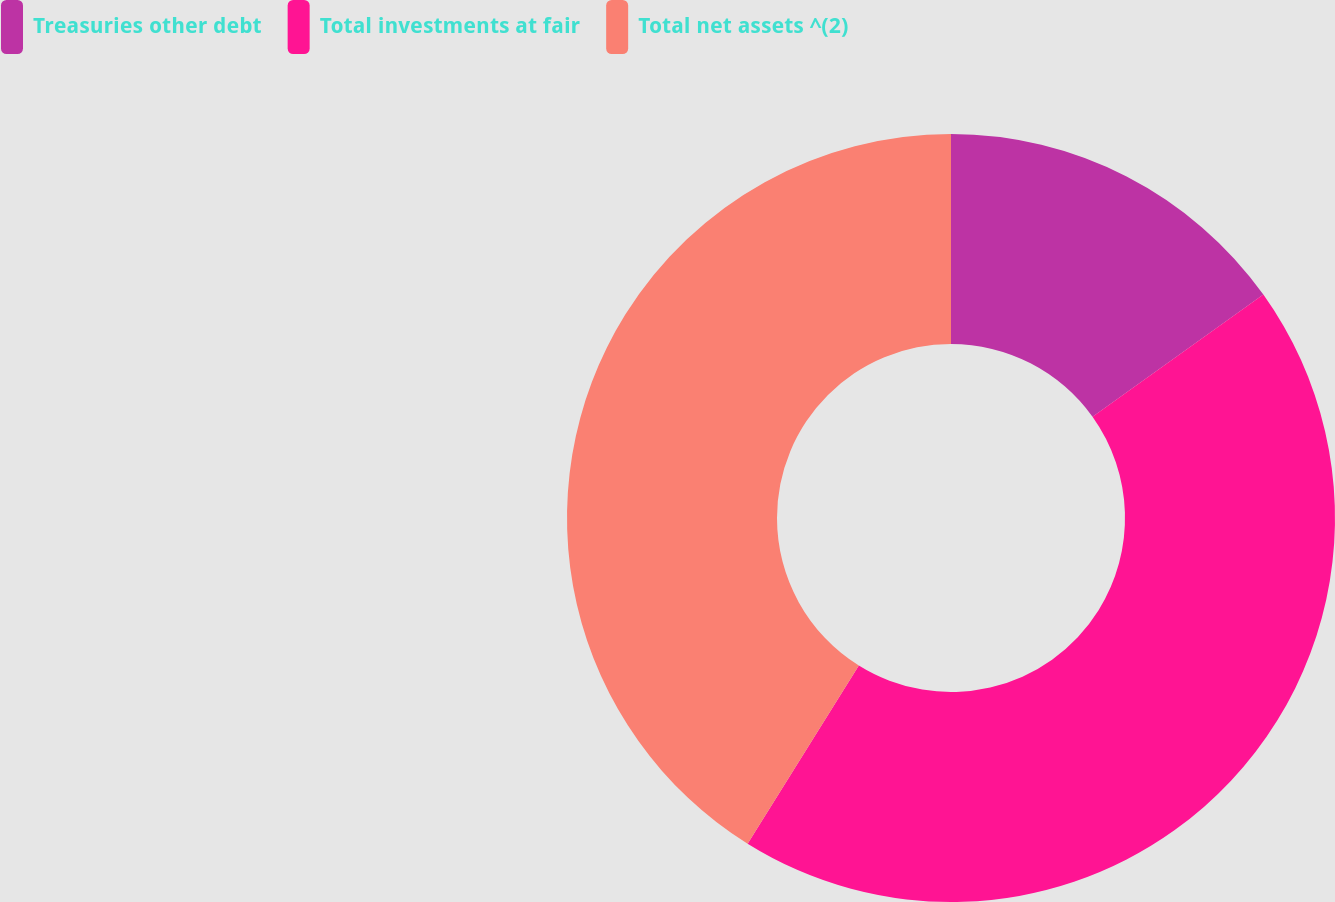Convert chart to OTSL. <chart><loc_0><loc_0><loc_500><loc_500><pie_chart><fcel>Treasuries other debt<fcel>Total investments at fair<fcel>Total net assets ^(2)<nl><fcel>15.12%<fcel>43.77%<fcel>41.12%<nl></chart> 